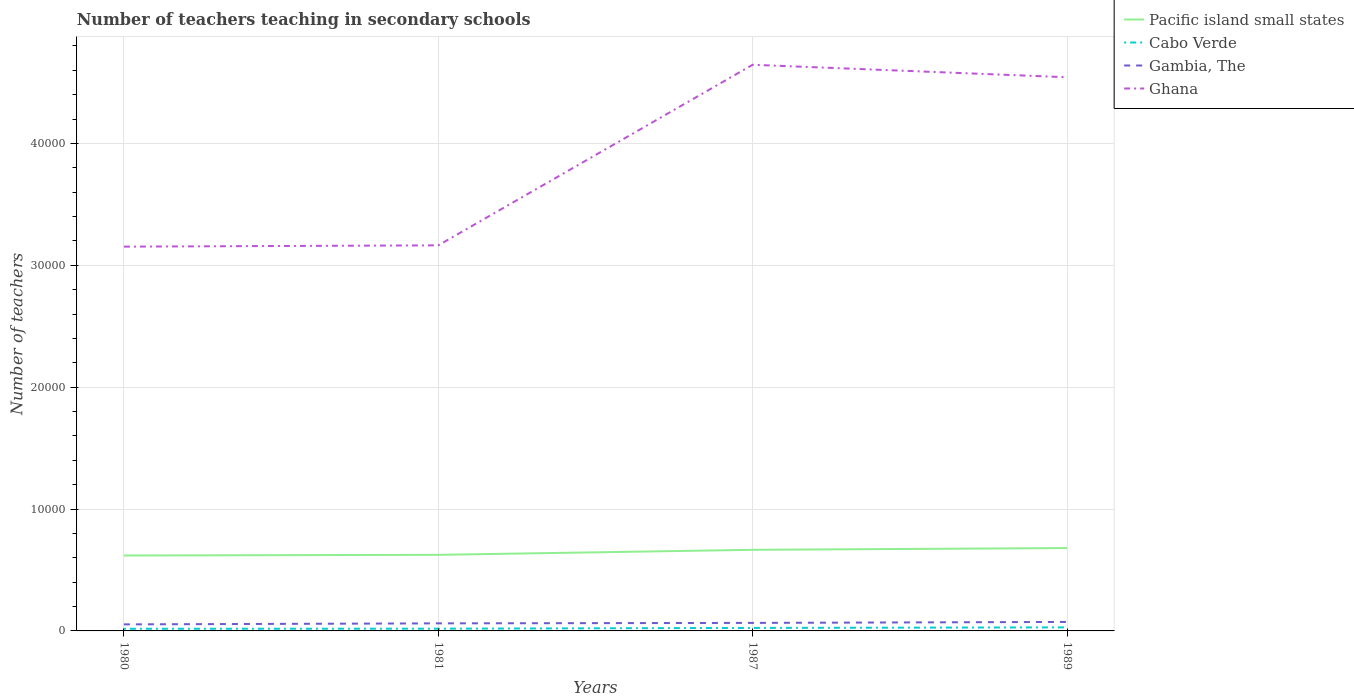How many different coloured lines are there?
Offer a terse response. 4. Is the number of lines equal to the number of legend labels?
Provide a succinct answer. Yes. Across all years, what is the maximum number of teachers teaching in secondary schools in Gambia, The?
Your answer should be very brief. 537. In which year was the number of teachers teaching in secondary schools in Cabo Verde maximum?
Ensure brevity in your answer.  1980. What is the total number of teachers teaching in secondary schools in Gambia, The in the graph?
Your answer should be very brief. -118. What is the difference between the highest and the second highest number of teachers teaching in secondary schools in Ghana?
Give a very brief answer. 1.49e+04. What is the difference between two consecutive major ticks on the Y-axis?
Provide a short and direct response. 10000. Are the values on the major ticks of Y-axis written in scientific E-notation?
Offer a terse response. No. Does the graph contain grids?
Ensure brevity in your answer.  Yes. Where does the legend appear in the graph?
Offer a terse response. Top right. How are the legend labels stacked?
Your answer should be very brief. Vertical. What is the title of the graph?
Offer a very short reply. Number of teachers teaching in secondary schools. What is the label or title of the Y-axis?
Provide a succinct answer. Number of teachers. What is the Number of teachers in Pacific island small states in 1980?
Provide a succinct answer. 6188.35. What is the Number of teachers in Cabo Verde in 1980?
Offer a terse response. 176. What is the Number of teachers in Gambia, The in 1980?
Offer a terse response. 537. What is the Number of teachers in Ghana in 1980?
Provide a short and direct response. 3.15e+04. What is the Number of teachers of Pacific island small states in 1981?
Offer a very short reply. 6243.49. What is the Number of teachers in Cabo Verde in 1981?
Provide a succinct answer. 184. What is the Number of teachers of Gambia, The in 1981?
Provide a succinct answer. 620. What is the Number of teachers of Ghana in 1981?
Give a very brief answer. 3.16e+04. What is the Number of teachers in Pacific island small states in 1987?
Your answer should be very brief. 6655.08. What is the Number of teachers of Cabo Verde in 1987?
Ensure brevity in your answer.  247. What is the Number of teachers in Gambia, The in 1987?
Your response must be concise. 658. What is the Number of teachers of Ghana in 1987?
Provide a succinct answer. 4.65e+04. What is the Number of teachers in Pacific island small states in 1989?
Your answer should be very brief. 6798.7. What is the Number of teachers in Cabo Verde in 1989?
Make the answer very short. 291. What is the Number of teachers of Gambia, The in 1989?
Ensure brevity in your answer.  738. What is the Number of teachers of Ghana in 1989?
Provide a short and direct response. 4.54e+04. Across all years, what is the maximum Number of teachers of Pacific island small states?
Keep it short and to the point. 6798.7. Across all years, what is the maximum Number of teachers in Cabo Verde?
Give a very brief answer. 291. Across all years, what is the maximum Number of teachers of Gambia, The?
Provide a short and direct response. 738. Across all years, what is the maximum Number of teachers in Ghana?
Make the answer very short. 4.65e+04. Across all years, what is the minimum Number of teachers of Pacific island small states?
Offer a very short reply. 6188.35. Across all years, what is the minimum Number of teachers of Cabo Verde?
Give a very brief answer. 176. Across all years, what is the minimum Number of teachers in Gambia, The?
Provide a succinct answer. 537. Across all years, what is the minimum Number of teachers in Ghana?
Give a very brief answer. 3.15e+04. What is the total Number of teachers of Pacific island small states in the graph?
Your response must be concise. 2.59e+04. What is the total Number of teachers in Cabo Verde in the graph?
Provide a short and direct response. 898. What is the total Number of teachers in Gambia, The in the graph?
Keep it short and to the point. 2553. What is the total Number of teachers of Ghana in the graph?
Provide a short and direct response. 1.55e+05. What is the difference between the Number of teachers in Pacific island small states in 1980 and that in 1981?
Ensure brevity in your answer.  -55.14. What is the difference between the Number of teachers in Gambia, The in 1980 and that in 1981?
Keep it short and to the point. -83. What is the difference between the Number of teachers in Ghana in 1980 and that in 1981?
Your response must be concise. -106. What is the difference between the Number of teachers of Pacific island small states in 1980 and that in 1987?
Give a very brief answer. -466.73. What is the difference between the Number of teachers of Cabo Verde in 1980 and that in 1987?
Offer a very short reply. -71. What is the difference between the Number of teachers of Gambia, The in 1980 and that in 1987?
Keep it short and to the point. -121. What is the difference between the Number of teachers of Ghana in 1980 and that in 1987?
Offer a terse response. -1.49e+04. What is the difference between the Number of teachers of Pacific island small states in 1980 and that in 1989?
Offer a very short reply. -610.35. What is the difference between the Number of teachers in Cabo Verde in 1980 and that in 1989?
Your answer should be compact. -115. What is the difference between the Number of teachers in Gambia, The in 1980 and that in 1989?
Your answer should be compact. -201. What is the difference between the Number of teachers of Ghana in 1980 and that in 1989?
Give a very brief answer. -1.39e+04. What is the difference between the Number of teachers of Pacific island small states in 1981 and that in 1987?
Ensure brevity in your answer.  -411.59. What is the difference between the Number of teachers in Cabo Verde in 1981 and that in 1987?
Your answer should be compact. -63. What is the difference between the Number of teachers of Gambia, The in 1981 and that in 1987?
Give a very brief answer. -38. What is the difference between the Number of teachers in Ghana in 1981 and that in 1987?
Provide a short and direct response. -1.48e+04. What is the difference between the Number of teachers of Pacific island small states in 1981 and that in 1989?
Keep it short and to the point. -555.21. What is the difference between the Number of teachers in Cabo Verde in 1981 and that in 1989?
Give a very brief answer. -107. What is the difference between the Number of teachers in Gambia, The in 1981 and that in 1989?
Make the answer very short. -118. What is the difference between the Number of teachers of Ghana in 1981 and that in 1989?
Your response must be concise. -1.38e+04. What is the difference between the Number of teachers of Pacific island small states in 1987 and that in 1989?
Offer a terse response. -143.62. What is the difference between the Number of teachers in Cabo Verde in 1987 and that in 1989?
Provide a short and direct response. -44. What is the difference between the Number of teachers of Gambia, The in 1987 and that in 1989?
Your answer should be very brief. -80. What is the difference between the Number of teachers in Ghana in 1987 and that in 1989?
Keep it short and to the point. 1023. What is the difference between the Number of teachers of Pacific island small states in 1980 and the Number of teachers of Cabo Verde in 1981?
Provide a succinct answer. 6004.35. What is the difference between the Number of teachers of Pacific island small states in 1980 and the Number of teachers of Gambia, The in 1981?
Your response must be concise. 5568.35. What is the difference between the Number of teachers of Pacific island small states in 1980 and the Number of teachers of Ghana in 1981?
Ensure brevity in your answer.  -2.54e+04. What is the difference between the Number of teachers in Cabo Verde in 1980 and the Number of teachers in Gambia, The in 1981?
Provide a short and direct response. -444. What is the difference between the Number of teachers in Cabo Verde in 1980 and the Number of teachers in Ghana in 1981?
Keep it short and to the point. -3.15e+04. What is the difference between the Number of teachers in Gambia, The in 1980 and the Number of teachers in Ghana in 1981?
Give a very brief answer. -3.11e+04. What is the difference between the Number of teachers in Pacific island small states in 1980 and the Number of teachers in Cabo Verde in 1987?
Keep it short and to the point. 5941.35. What is the difference between the Number of teachers in Pacific island small states in 1980 and the Number of teachers in Gambia, The in 1987?
Your answer should be compact. 5530.35. What is the difference between the Number of teachers of Pacific island small states in 1980 and the Number of teachers of Ghana in 1987?
Your answer should be very brief. -4.03e+04. What is the difference between the Number of teachers in Cabo Verde in 1980 and the Number of teachers in Gambia, The in 1987?
Your response must be concise. -482. What is the difference between the Number of teachers of Cabo Verde in 1980 and the Number of teachers of Ghana in 1987?
Make the answer very short. -4.63e+04. What is the difference between the Number of teachers of Gambia, The in 1980 and the Number of teachers of Ghana in 1987?
Give a very brief answer. -4.59e+04. What is the difference between the Number of teachers in Pacific island small states in 1980 and the Number of teachers in Cabo Verde in 1989?
Offer a very short reply. 5897.35. What is the difference between the Number of teachers of Pacific island small states in 1980 and the Number of teachers of Gambia, The in 1989?
Offer a very short reply. 5450.35. What is the difference between the Number of teachers in Pacific island small states in 1980 and the Number of teachers in Ghana in 1989?
Give a very brief answer. -3.92e+04. What is the difference between the Number of teachers of Cabo Verde in 1980 and the Number of teachers of Gambia, The in 1989?
Your response must be concise. -562. What is the difference between the Number of teachers of Cabo Verde in 1980 and the Number of teachers of Ghana in 1989?
Your answer should be compact. -4.53e+04. What is the difference between the Number of teachers of Gambia, The in 1980 and the Number of teachers of Ghana in 1989?
Offer a terse response. -4.49e+04. What is the difference between the Number of teachers of Pacific island small states in 1981 and the Number of teachers of Cabo Verde in 1987?
Give a very brief answer. 5996.49. What is the difference between the Number of teachers in Pacific island small states in 1981 and the Number of teachers in Gambia, The in 1987?
Ensure brevity in your answer.  5585.49. What is the difference between the Number of teachers of Pacific island small states in 1981 and the Number of teachers of Ghana in 1987?
Provide a short and direct response. -4.02e+04. What is the difference between the Number of teachers in Cabo Verde in 1981 and the Number of teachers in Gambia, The in 1987?
Keep it short and to the point. -474. What is the difference between the Number of teachers of Cabo Verde in 1981 and the Number of teachers of Ghana in 1987?
Your response must be concise. -4.63e+04. What is the difference between the Number of teachers of Gambia, The in 1981 and the Number of teachers of Ghana in 1987?
Offer a very short reply. -4.58e+04. What is the difference between the Number of teachers in Pacific island small states in 1981 and the Number of teachers in Cabo Verde in 1989?
Provide a succinct answer. 5952.49. What is the difference between the Number of teachers in Pacific island small states in 1981 and the Number of teachers in Gambia, The in 1989?
Keep it short and to the point. 5505.49. What is the difference between the Number of teachers of Pacific island small states in 1981 and the Number of teachers of Ghana in 1989?
Offer a terse response. -3.92e+04. What is the difference between the Number of teachers in Cabo Verde in 1981 and the Number of teachers in Gambia, The in 1989?
Make the answer very short. -554. What is the difference between the Number of teachers in Cabo Verde in 1981 and the Number of teachers in Ghana in 1989?
Ensure brevity in your answer.  -4.52e+04. What is the difference between the Number of teachers in Gambia, The in 1981 and the Number of teachers in Ghana in 1989?
Ensure brevity in your answer.  -4.48e+04. What is the difference between the Number of teachers of Pacific island small states in 1987 and the Number of teachers of Cabo Verde in 1989?
Your answer should be very brief. 6364.08. What is the difference between the Number of teachers of Pacific island small states in 1987 and the Number of teachers of Gambia, The in 1989?
Provide a succinct answer. 5917.08. What is the difference between the Number of teachers of Pacific island small states in 1987 and the Number of teachers of Ghana in 1989?
Your response must be concise. -3.88e+04. What is the difference between the Number of teachers of Cabo Verde in 1987 and the Number of teachers of Gambia, The in 1989?
Your response must be concise. -491. What is the difference between the Number of teachers of Cabo Verde in 1987 and the Number of teachers of Ghana in 1989?
Make the answer very short. -4.52e+04. What is the difference between the Number of teachers of Gambia, The in 1987 and the Number of teachers of Ghana in 1989?
Keep it short and to the point. -4.48e+04. What is the average Number of teachers of Pacific island small states per year?
Provide a succinct answer. 6471.4. What is the average Number of teachers in Cabo Verde per year?
Your answer should be compact. 224.5. What is the average Number of teachers of Gambia, The per year?
Ensure brevity in your answer.  638.25. What is the average Number of teachers in Ghana per year?
Your response must be concise. 3.88e+04. In the year 1980, what is the difference between the Number of teachers in Pacific island small states and Number of teachers in Cabo Verde?
Ensure brevity in your answer.  6012.35. In the year 1980, what is the difference between the Number of teachers in Pacific island small states and Number of teachers in Gambia, The?
Provide a short and direct response. 5651.35. In the year 1980, what is the difference between the Number of teachers in Pacific island small states and Number of teachers in Ghana?
Your answer should be compact. -2.53e+04. In the year 1980, what is the difference between the Number of teachers in Cabo Verde and Number of teachers in Gambia, The?
Provide a succinct answer. -361. In the year 1980, what is the difference between the Number of teachers in Cabo Verde and Number of teachers in Ghana?
Offer a very short reply. -3.14e+04. In the year 1980, what is the difference between the Number of teachers in Gambia, The and Number of teachers in Ghana?
Ensure brevity in your answer.  -3.10e+04. In the year 1981, what is the difference between the Number of teachers of Pacific island small states and Number of teachers of Cabo Verde?
Offer a very short reply. 6059.49. In the year 1981, what is the difference between the Number of teachers in Pacific island small states and Number of teachers in Gambia, The?
Offer a terse response. 5623.49. In the year 1981, what is the difference between the Number of teachers in Pacific island small states and Number of teachers in Ghana?
Your answer should be very brief. -2.54e+04. In the year 1981, what is the difference between the Number of teachers in Cabo Verde and Number of teachers in Gambia, The?
Offer a very short reply. -436. In the year 1981, what is the difference between the Number of teachers in Cabo Verde and Number of teachers in Ghana?
Your answer should be very brief. -3.15e+04. In the year 1981, what is the difference between the Number of teachers in Gambia, The and Number of teachers in Ghana?
Your answer should be compact. -3.10e+04. In the year 1987, what is the difference between the Number of teachers of Pacific island small states and Number of teachers of Cabo Verde?
Your answer should be very brief. 6408.08. In the year 1987, what is the difference between the Number of teachers in Pacific island small states and Number of teachers in Gambia, The?
Give a very brief answer. 5997.08. In the year 1987, what is the difference between the Number of teachers in Pacific island small states and Number of teachers in Ghana?
Provide a short and direct response. -3.98e+04. In the year 1987, what is the difference between the Number of teachers of Cabo Verde and Number of teachers of Gambia, The?
Keep it short and to the point. -411. In the year 1987, what is the difference between the Number of teachers of Cabo Verde and Number of teachers of Ghana?
Your response must be concise. -4.62e+04. In the year 1987, what is the difference between the Number of teachers of Gambia, The and Number of teachers of Ghana?
Your answer should be compact. -4.58e+04. In the year 1989, what is the difference between the Number of teachers of Pacific island small states and Number of teachers of Cabo Verde?
Your answer should be compact. 6507.7. In the year 1989, what is the difference between the Number of teachers of Pacific island small states and Number of teachers of Gambia, The?
Ensure brevity in your answer.  6060.7. In the year 1989, what is the difference between the Number of teachers in Pacific island small states and Number of teachers in Ghana?
Offer a very short reply. -3.86e+04. In the year 1989, what is the difference between the Number of teachers in Cabo Verde and Number of teachers in Gambia, The?
Ensure brevity in your answer.  -447. In the year 1989, what is the difference between the Number of teachers in Cabo Verde and Number of teachers in Ghana?
Give a very brief answer. -4.51e+04. In the year 1989, what is the difference between the Number of teachers of Gambia, The and Number of teachers of Ghana?
Provide a short and direct response. -4.47e+04. What is the ratio of the Number of teachers in Cabo Verde in 1980 to that in 1981?
Offer a very short reply. 0.96. What is the ratio of the Number of teachers in Gambia, The in 1980 to that in 1981?
Keep it short and to the point. 0.87. What is the ratio of the Number of teachers in Pacific island small states in 1980 to that in 1987?
Provide a short and direct response. 0.93. What is the ratio of the Number of teachers of Cabo Verde in 1980 to that in 1987?
Your response must be concise. 0.71. What is the ratio of the Number of teachers of Gambia, The in 1980 to that in 1987?
Your answer should be compact. 0.82. What is the ratio of the Number of teachers of Ghana in 1980 to that in 1987?
Your response must be concise. 0.68. What is the ratio of the Number of teachers in Pacific island small states in 1980 to that in 1989?
Ensure brevity in your answer.  0.91. What is the ratio of the Number of teachers in Cabo Verde in 1980 to that in 1989?
Offer a terse response. 0.6. What is the ratio of the Number of teachers in Gambia, The in 1980 to that in 1989?
Keep it short and to the point. 0.73. What is the ratio of the Number of teachers of Ghana in 1980 to that in 1989?
Your response must be concise. 0.69. What is the ratio of the Number of teachers in Pacific island small states in 1981 to that in 1987?
Offer a very short reply. 0.94. What is the ratio of the Number of teachers in Cabo Verde in 1981 to that in 1987?
Your response must be concise. 0.74. What is the ratio of the Number of teachers in Gambia, The in 1981 to that in 1987?
Offer a very short reply. 0.94. What is the ratio of the Number of teachers in Ghana in 1981 to that in 1987?
Provide a succinct answer. 0.68. What is the ratio of the Number of teachers in Pacific island small states in 1981 to that in 1989?
Keep it short and to the point. 0.92. What is the ratio of the Number of teachers of Cabo Verde in 1981 to that in 1989?
Keep it short and to the point. 0.63. What is the ratio of the Number of teachers of Gambia, The in 1981 to that in 1989?
Offer a terse response. 0.84. What is the ratio of the Number of teachers of Ghana in 1981 to that in 1989?
Offer a very short reply. 0.7. What is the ratio of the Number of teachers of Pacific island small states in 1987 to that in 1989?
Your response must be concise. 0.98. What is the ratio of the Number of teachers in Cabo Verde in 1987 to that in 1989?
Provide a short and direct response. 0.85. What is the ratio of the Number of teachers in Gambia, The in 1987 to that in 1989?
Your answer should be very brief. 0.89. What is the ratio of the Number of teachers in Ghana in 1987 to that in 1989?
Ensure brevity in your answer.  1.02. What is the difference between the highest and the second highest Number of teachers in Pacific island small states?
Keep it short and to the point. 143.62. What is the difference between the highest and the second highest Number of teachers in Ghana?
Your answer should be very brief. 1023. What is the difference between the highest and the lowest Number of teachers of Pacific island small states?
Give a very brief answer. 610.35. What is the difference between the highest and the lowest Number of teachers of Cabo Verde?
Provide a short and direct response. 115. What is the difference between the highest and the lowest Number of teachers of Gambia, The?
Your response must be concise. 201. What is the difference between the highest and the lowest Number of teachers of Ghana?
Offer a terse response. 1.49e+04. 